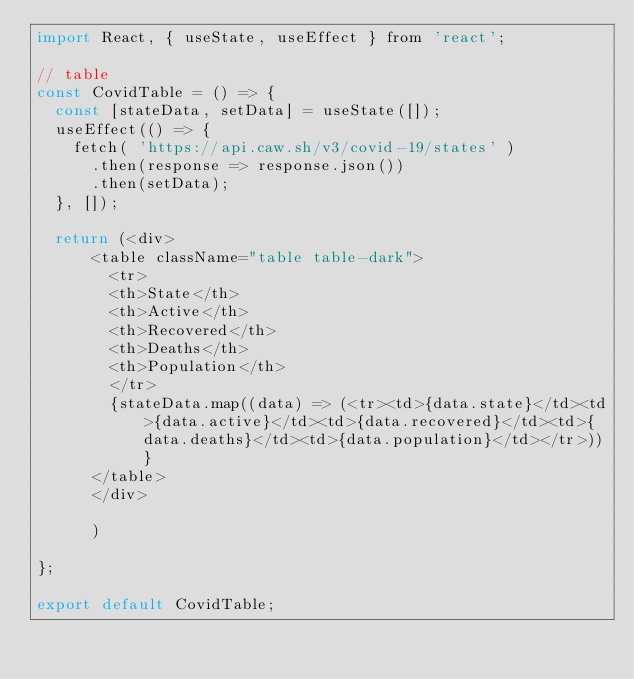<code> <loc_0><loc_0><loc_500><loc_500><_JavaScript_>import React, { useState, useEffect } from 'react';

// table
const CovidTable = () => {
  const [stateData, setData] = useState([]);
  useEffect(() => {
    fetch( 'https://api.caw.sh/v3/covid-19/states' )
      .then(response => response.json())
      .then(setData);
  }, []);

  return (<div>
      <table className="table table-dark">
        <tr>
        <th>State</th>
        <th>Active</th>
        <th>Recovered</th>
        <th>Deaths</th>
        <th>Population</th>
        </tr>
        {stateData.map((data) => (<tr><td>{data.state}</td><td>{data.active}</td><td>{data.recovered}</td><td>{data.deaths}</td><td>{data.population}</td></tr>))}
      </table>
      </div>

      )

};

export default CovidTable;
</code> 